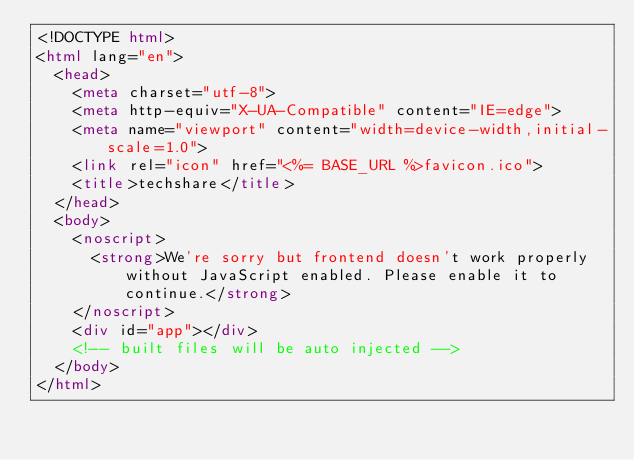<code> <loc_0><loc_0><loc_500><loc_500><_HTML_><!DOCTYPE html>
<html lang="en">
  <head>
    <meta charset="utf-8">
    <meta http-equiv="X-UA-Compatible" content="IE=edge">
    <meta name="viewport" content="width=device-width,initial-scale=1.0">
    <link rel="icon" href="<%= BASE_URL %>favicon.ico">
    <title>techshare</title>
  </head>
  <body>
    <noscript>
      <strong>We're sorry but frontend doesn't work properly without JavaScript enabled. Please enable it to continue.</strong>
    </noscript>
    <div id="app"></div>
    <!-- built files will be auto injected -->
  </body>
</html>
</code> 